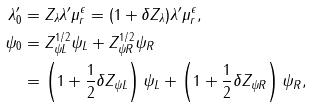Convert formula to latex. <formula><loc_0><loc_0><loc_500><loc_500>\lambda ^ { \prime } _ { 0 } & = Z _ { \lambda } \lambda ^ { \prime } \mu _ { r } ^ { \epsilon } = ( 1 + \delta Z _ { \lambda } ) \lambda ^ { \prime } \mu _ { r } ^ { \epsilon } , \\ \psi _ { 0 } & = Z _ { \psi { L } } ^ { 1 / 2 } \psi _ { L } + Z _ { \psi { R } } ^ { 1 / 2 } \psi _ { R } \\ & = \left ( 1 + \frac { 1 } { 2 } \delta Z _ { \psi { L } } \right ) \psi _ { L } + \left ( 1 + \frac { 1 } { 2 } \delta Z _ { \psi { R } } \right ) \psi _ { R } ,</formula> 